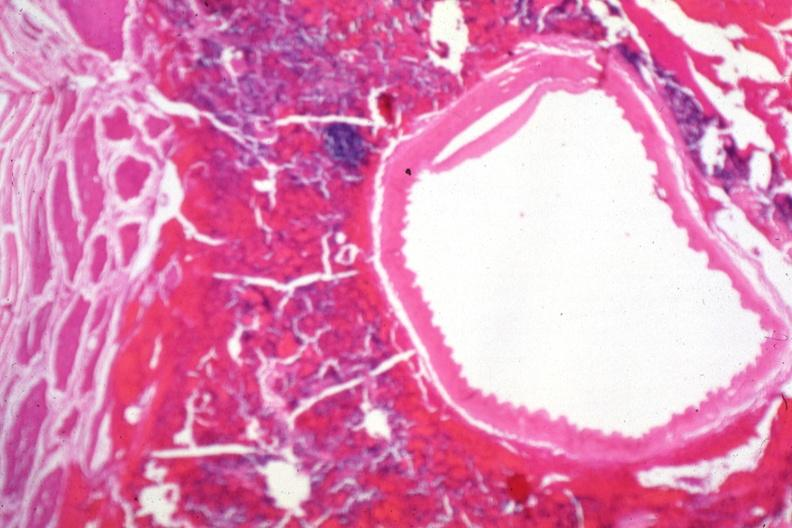s pituitary present?
Answer the question using a single word or phrase. Yes 